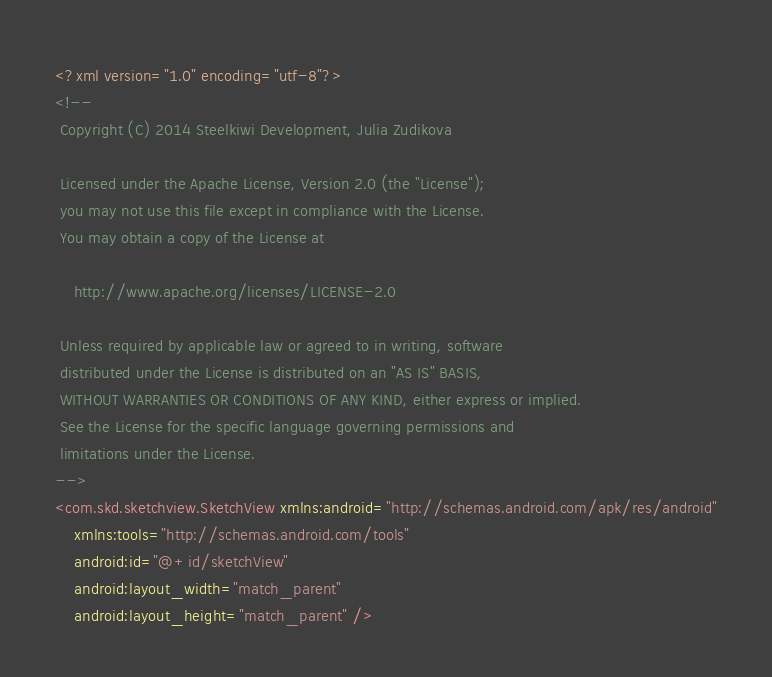<code> <loc_0><loc_0><loc_500><loc_500><_XML_><?xml version="1.0" encoding="utf-8"?>
<!--
 Copyright (C) 2014 Steelkiwi Development, Julia Zudikova
  
 Licensed under the Apache License, Version 2.0 (the "License");
 you may not use this file except in compliance with the License.
 You may obtain a copy of the License at
  
	http://www.apache.org/licenses/LICENSE-2.0
  
 Unless required by applicable law or agreed to in writing, software
 distributed under the License is distributed on an "AS IS" BASIS,
 WITHOUT WARRANTIES OR CONDITIONS OF ANY KIND, either express or implied.
 See the License for the specific language governing permissions and
 limitations under the License.
-->
<com.skd.sketchview.SketchView xmlns:android="http://schemas.android.com/apk/res/android"
    xmlns:tools="http://schemas.android.com/tools"
    android:id="@+id/sketchView"
    android:layout_width="match_parent"
    android:layout_height="match_parent" />
</code> 